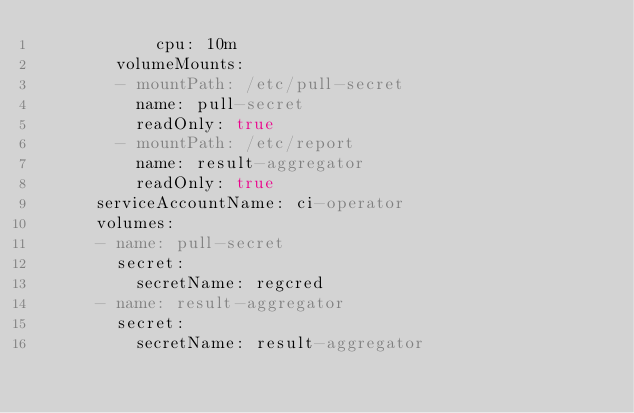<code> <loc_0><loc_0><loc_500><loc_500><_YAML_>            cpu: 10m
        volumeMounts:
        - mountPath: /etc/pull-secret
          name: pull-secret
          readOnly: true
        - mountPath: /etc/report
          name: result-aggregator
          readOnly: true
      serviceAccountName: ci-operator
      volumes:
      - name: pull-secret
        secret:
          secretName: regcred
      - name: result-aggregator
        secret:
          secretName: result-aggregator
</code> 